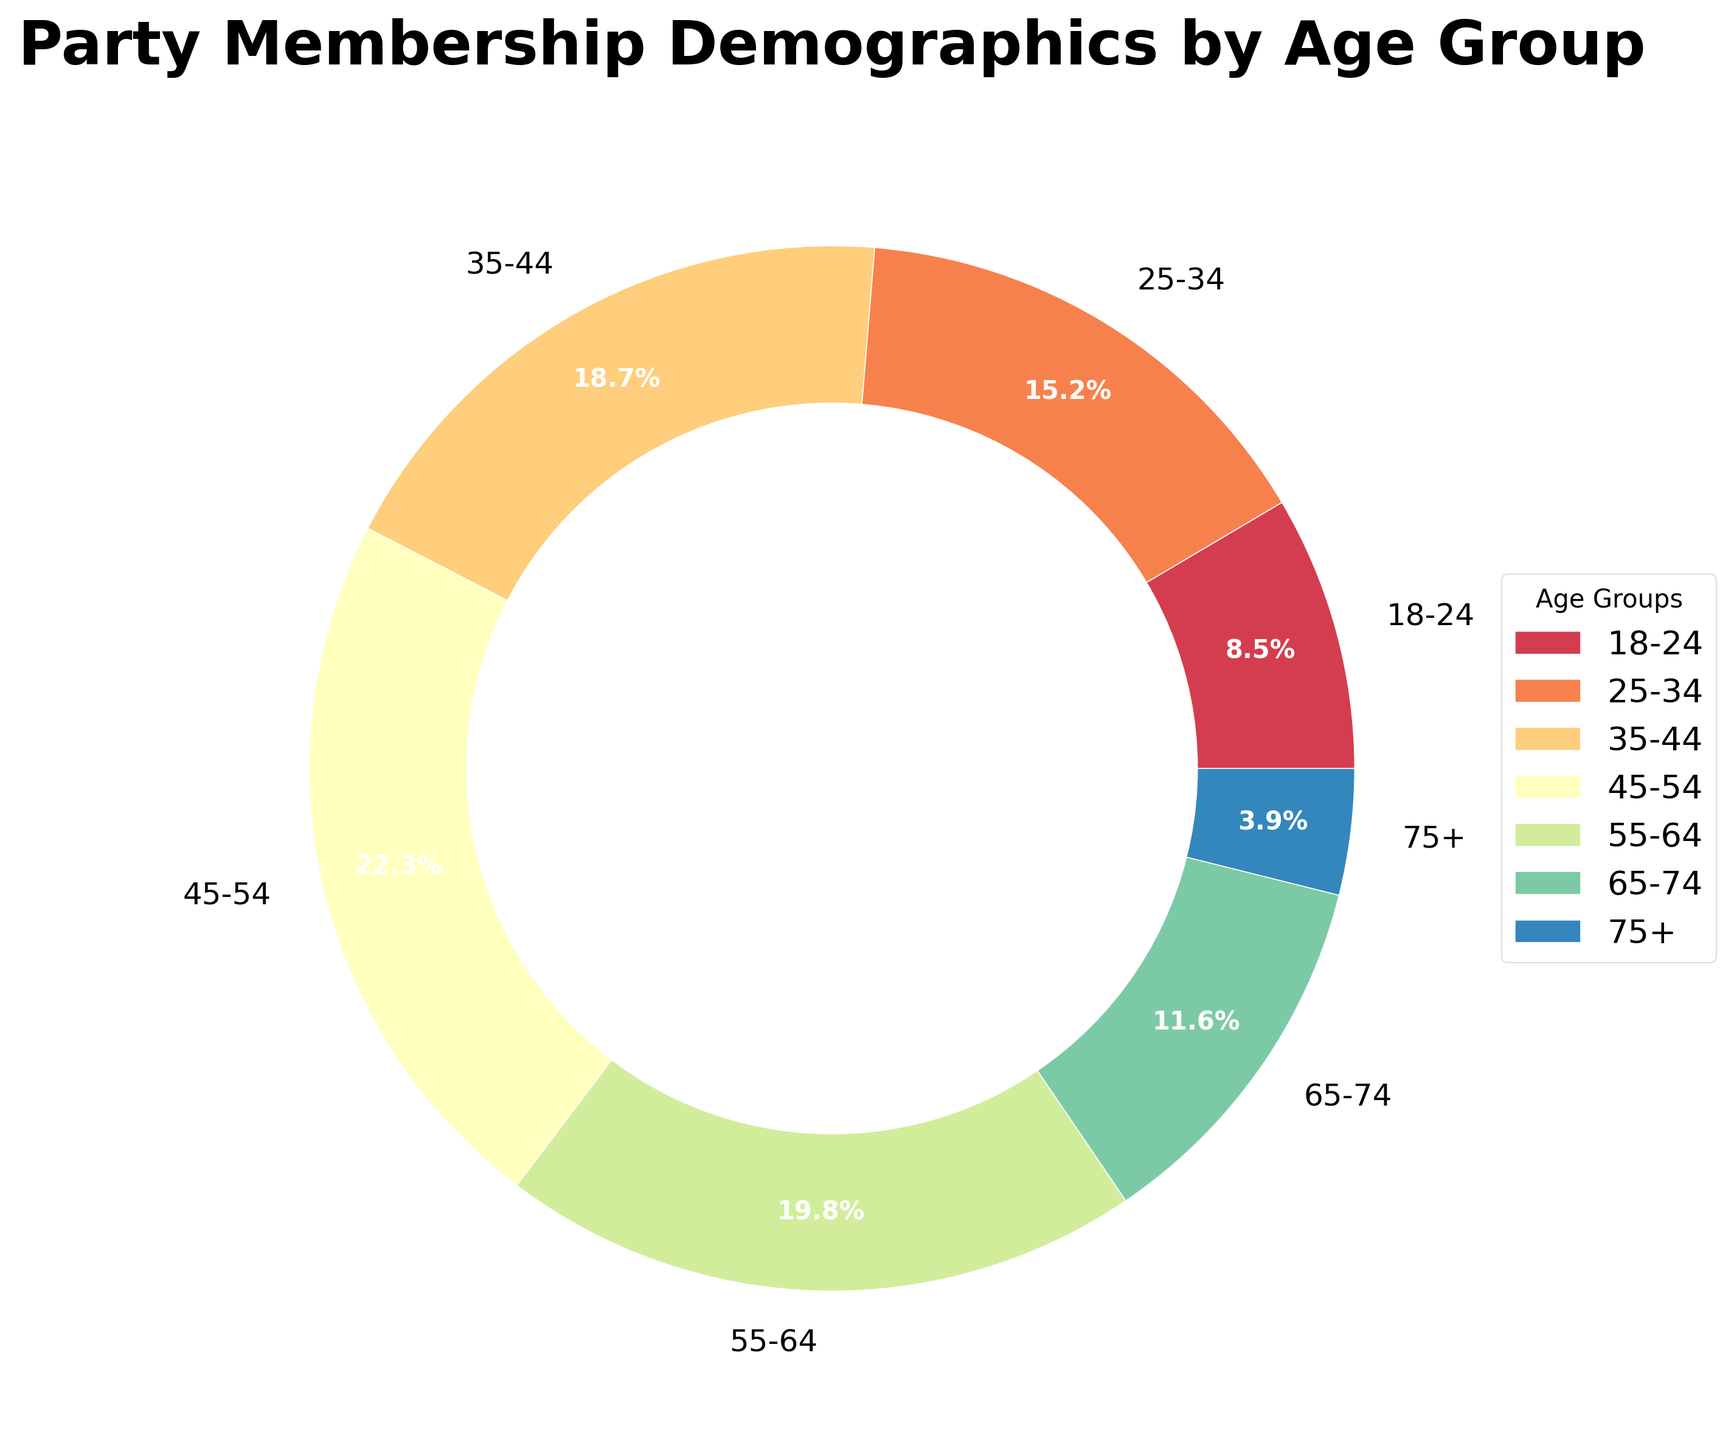Which age group has the highest percentage of party membership? By observing the segments of the pie chart, the age group with the largest wedge represents the highest percentage. According to the data provided, the 45-54 age group has the highest percentage at 22.3%.
Answer: 45-54 What is the combined percentage of party members aged 55 and above? To get the combined percentage, sum the percentages of the age groups that are 55 and above: 19.8% (55-64) + 11.6% (65-74) + 3.9% (75+). The total is 19.8 + 11.6 + 3.9 = 35.3%.
Answer: 35.3% Which two adjacent age groups have the smallest combined percentage, and what is it? To find this, calculate the sums of percentages of adjacent age groups and compare them: 
- 18-24 and 25-34: 8.5 + 15.2 = 23.7
- 25-34 and 35-44: 15.2 + 18.7 = 33.9
- 35-44 and 45-54: 18.7 + 22.3 = 41.0
- 45-54 and 55-64: 22.3 + 19.8 = 42.1
- 55-64 and 65-74: 19.8 + 11.6 = 31.4
- 65-74 and 75+: 11.6 + 3.9 = 15.5
The smallest combined percentage occurs between the age groups 65-74 and 75+, which is 15.5%.
Answer: 65-74 and 75+, 15.5% How does the percentage of the 18-24 age group compare to that of the 75+ age group? By simply comparing the percentages of the two groups, we see that the 18-24 age group has 8.5%, while the 75+ age group has 3.9%. The 18-24 age group has a higher percentage.
Answer: 18-24 is higher What color represents the 45-54 age group on the pie chart? By checking the visual attribute of the 45-54 segment on the pie chart, we can see that it is represented by the third segment counterclockwise from the top. This segment typically has a distinct color which is visible on the chart.
Answer: (Please refer to the actual diagram for the color) Which age group has the second smallest representation in party membership, and what is that percentage? By identifying the smallest and second smallest segments on the pie chart, we note that the 75+ age group is the smallest at 3.9%. The next smallest segment would be the 18-24 age group at 8.5%.
Answer: 18-24, 8.5% What is the difference between the highest and lowest percentages of party memberships? Determine the highest percentage (22.3% for 45-54) and the lowest percentage (3.9% for 75+). The difference is calculated by subtracting the lowest percentage from the highest: 22.3% - 3.9% = 18.4%.
Answer: 18.4% Which age groups collectively make up over half of the party membership? Sum the percentages from highest to lowest until the sum exceeds 50%. The age groups 45-54 (22.3%) and 55-64 (19.8%) total 42.1%. Adding the next highest, 35-44 (18.7%), we get 42.1 + 18.7 = 60.8%, which is over half.
Answer: 45-54, 55-64, 35-44 